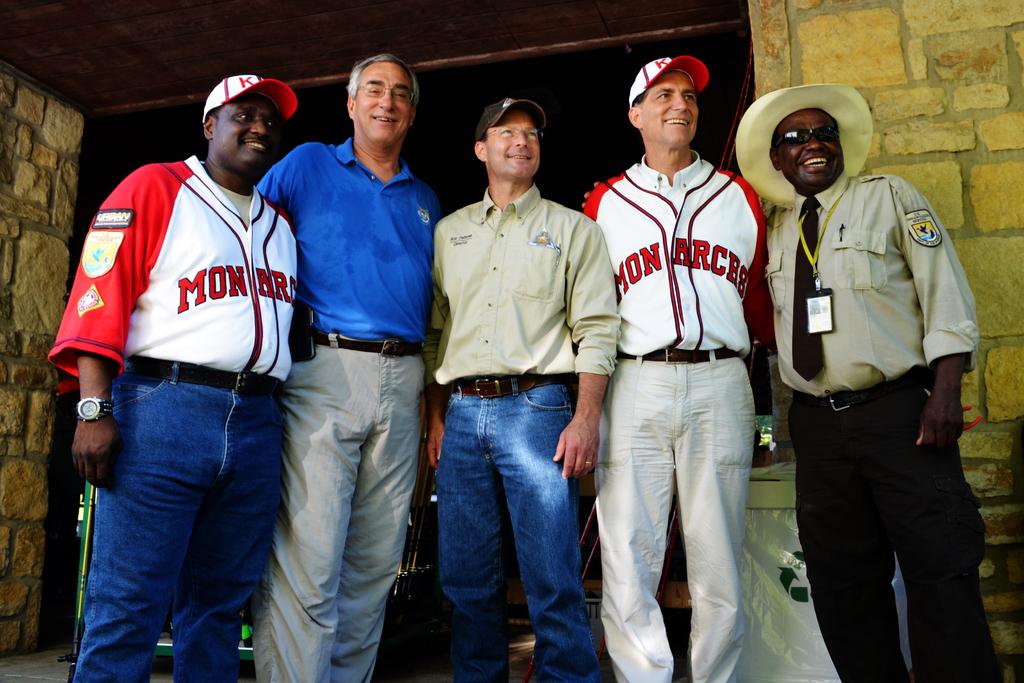What team are they on?
Your response must be concise. Monarces. 